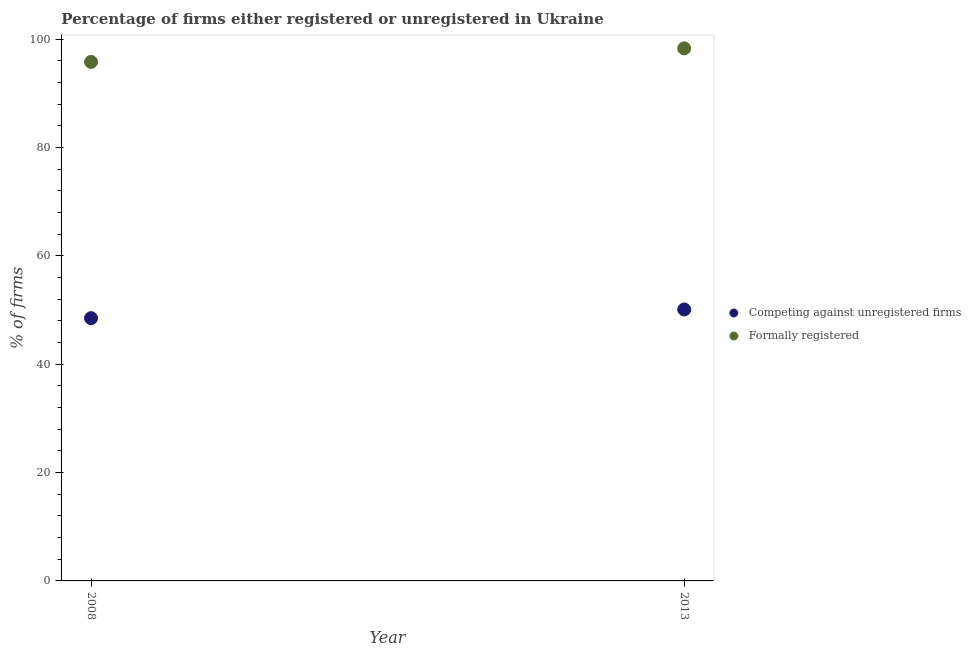What is the percentage of formally registered firms in 2008?
Your answer should be very brief. 95.8. Across all years, what is the maximum percentage of formally registered firms?
Your response must be concise. 98.3. Across all years, what is the minimum percentage of registered firms?
Give a very brief answer. 48.5. In which year was the percentage of formally registered firms maximum?
Ensure brevity in your answer.  2013. What is the total percentage of formally registered firms in the graph?
Your response must be concise. 194.1. What is the difference between the percentage of formally registered firms in 2013 and the percentage of registered firms in 2008?
Offer a terse response. 49.8. What is the average percentage of formally registered firms per year?
Your answer should be compact. 97.05. In the year 2013, what is the difference between the percentage of registered firms and percentage of formally registered firms?
Make the answer very short. -48.2. What is the ratio of the percentage of formally registered firms in 2008 to that in 2013?
Provide a succinct answer. 0.97. Is the percentage of registered firms in 2008 less than that in 2013?
Offer a terse response. Yes. Is the percentage of formally registered firms strictly greater than the percentage of registered firms over the years?
Offer a terse response. Yes. How many dotlines are there?
Keep it short and to the point. 2. Are the values on the major ticks of Y-axis written in scientific E-notation?
Make the answer very short. No. Does the graph contain grids?
Provide a succinct answer. No. Where does the legend appear in the graph?
Your answer should be compact. Center right. How are the legend labels stacked?
Offer a terse response. Vertical. What is the title of the graph?
Your response must be concise. Percentage of firms either registered or unregistered in Ukraine. What is the label or title of the X-axis?
Make the answer very short. Year. What is the label or title of the Y-axis?
Make the answer very short. % of firms. What is the % of firms of Competing against unregistered firms in 2008?
Make the answer very short. 48.5. What is the % of firms of Formally registered in 2008?
Offer a terse response. 95.8. What is the % of firms of Competing against unregistered firms in 2013?
Offer a very short reply. 50.1. What is the % of firms of Formally registered in 2013?
Your answer should be very brief. 98.3. Across all years, what is the maximum % of firms in Competing against unregistered firms?
Ensure brevity in your answer.  50.1. Across all years, what is the maximum % of firms of Formally registered?
Provide a short and direct response. 98.3. Across all years, what is the minimum % of firms in Competing against unregistered firms?
Provide a succinct answer. 48.5. Across all years, what is the minimum % of firms of Formally registered?
Your answer should be compact. 95.8. What is the total % of firms in Competing against unregistered firms in the graph?
Your answer should be very brief. 98.6. What is the total % of firms of Formally registered in the graph?
Keep it short and to the point. 194.1. What is the difference between the % of firms in Competing against unregistered firms in 2008 and that in 2013?
Your answer should be very brief. -1.6. What is the difference between the % of firms in Formally registered in 2008 and that in 2013?
Offer a very short reply. -2.5. What is the difference between the % of firms of Competing against unregistered firms in 2008 and the % of firms of Formally registered in 2013?
Offer a terse response. -49.8. What is the average % of firms of Competing against unregistered firms per year?
Offer a terse response. 49.3. What is the average % of firms of Formally registered per year?
Make the answer very short. 97.05. In the year 2008, what is the difference between the % of firms in Competing against unregistered firms and % of firms in Formally registered?
Keep it short and to the point. -47.3. In the year 2013, what is the difference between the % of firms of Competing against unregistered firms and % of firms of Formally registered?
Your response must be concise. -48.2. What is the ratio of the % of firms in Competing against unregistered firms in 2008 to that in 2013?
Your answer should be very brief. 0.97. What is the ratio of the % of firms in Formally registered in 2008 to that in 2013?
Offer a terse response. 0.97. What is the difference between the highest and the second highest % of firms in Formally registered?
Provide a short and direct response. 2.5. What is the difference between the highest and the lowest % of firms in Competing against unregistered firms?
Keep it short and to the point. 1.6. 